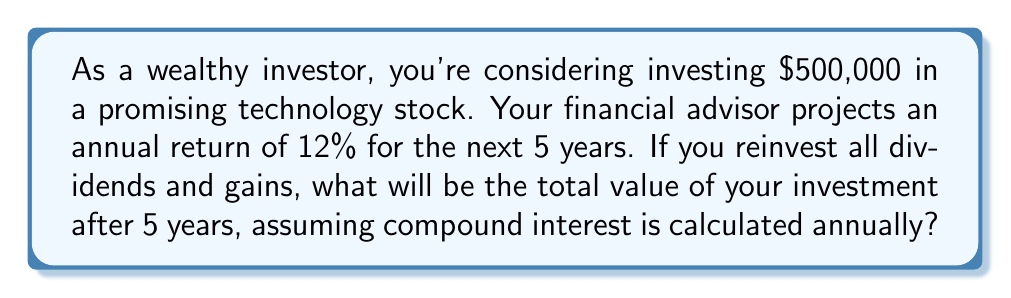Provide a solution to this math problem. To solve this problem, we'll use the compound interest formula:

$$A = P(1 + r)^n$$

Where:
$A$ = Final amount
$P$ = Principal (initial investment)
$r$ = Annual interest rate (as a decimal)
$n$ = Number of years

Given:
$P = \$500,000$
$r = 12\% = 0.12$
$n = 5$ years

Let's substitute these values into the formula:

$$A = 500,000(1 + 0.12)^5$$

Now, let's calculate step by step:

1) First, calculate $(1 + 0.12)^5$:
   $$(1.12)^5 = 1.12 \times 1.12 \times 1.12 \times 1.12 \times 1.12 = 1.7623416$$

2) Now multiply this result by the principal:
   $$500,000 \times 1.7623416 = 881,170.80$$

Therefore, after 5 years, the investment will grow to $881,170.80.
Answer: $881,170.80 